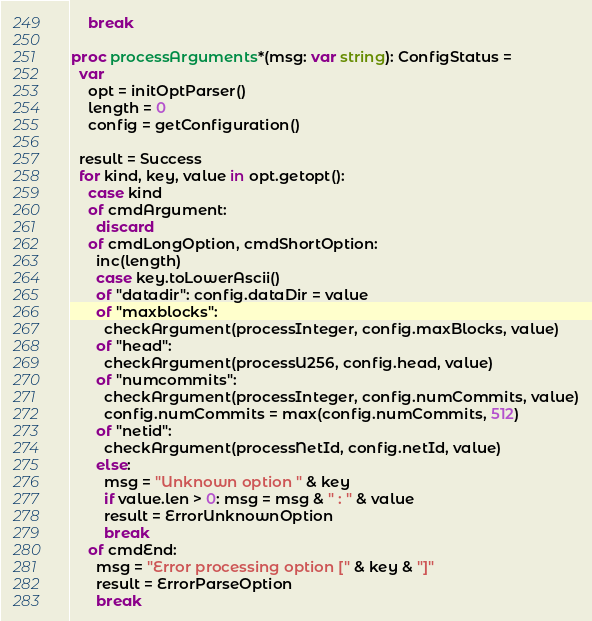Convert code to text. <code><loc_0><loc_0><loc_500><loc_500><_Nim_>    break

proc processArguments*(msg: var string): ConfigStatus =
  var
    opt = initOptParser()
    length = 0
    config = getConfiguration()

  result = Success
  for kind, key, value in opt.getopt():
    case kind
    of cmdArgument:
      discard
    of cmdLongOption, cmdShortOption:
      inc(length)
      case key.toLowerAscii()
      of "datadir": config.dataDir = value
      of "maxblocks":
        checkArgument(processInteger, config.maxBlocks, value)
      of "head":
        checkArgument(processU256, config.head, value)
      of "numcommits":
        checkArgument(processInteger, config.numCommits, value)
        config.numCommits = max(config.numCommits, 512)
      of "netid":
        checkArgument(processNetId, config.netId, value)
      else:
        msg = "Unknown option " & key
        if value.len > 0: msg = msg & " : " & value
        result = ErrorUnknownOption
        break
    of cmdEnd:
      msg = "Error processing option [" & key & "]"
      result = ErrorParseOption
      break
</code> 